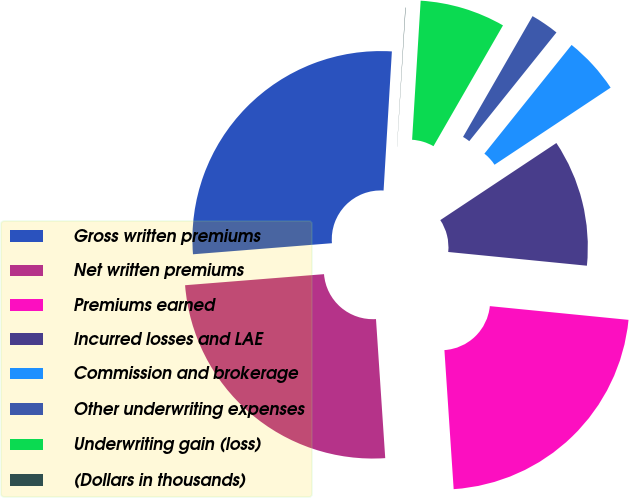<chart> <loc_0><loc_0><loc_500><loc_500><pie_chart><fcel>Gross written premiums<fcel>Net written premiums<fcel>Premiums earned<fcel>Incurred losses and LAE<fcel>Commission and brokerage<fcel>Other underwriting expenses<fcel>Underwriting gain (loss)<fcel>(Dollars in thousands)<nl><fcel>27.21%<fcel>24.79%<fcel>22.37%<fcel>10.9%<fcel>4.91%<fcel>2.45%<fcel>7.33%<fcel>0.03%<nl></chart> 